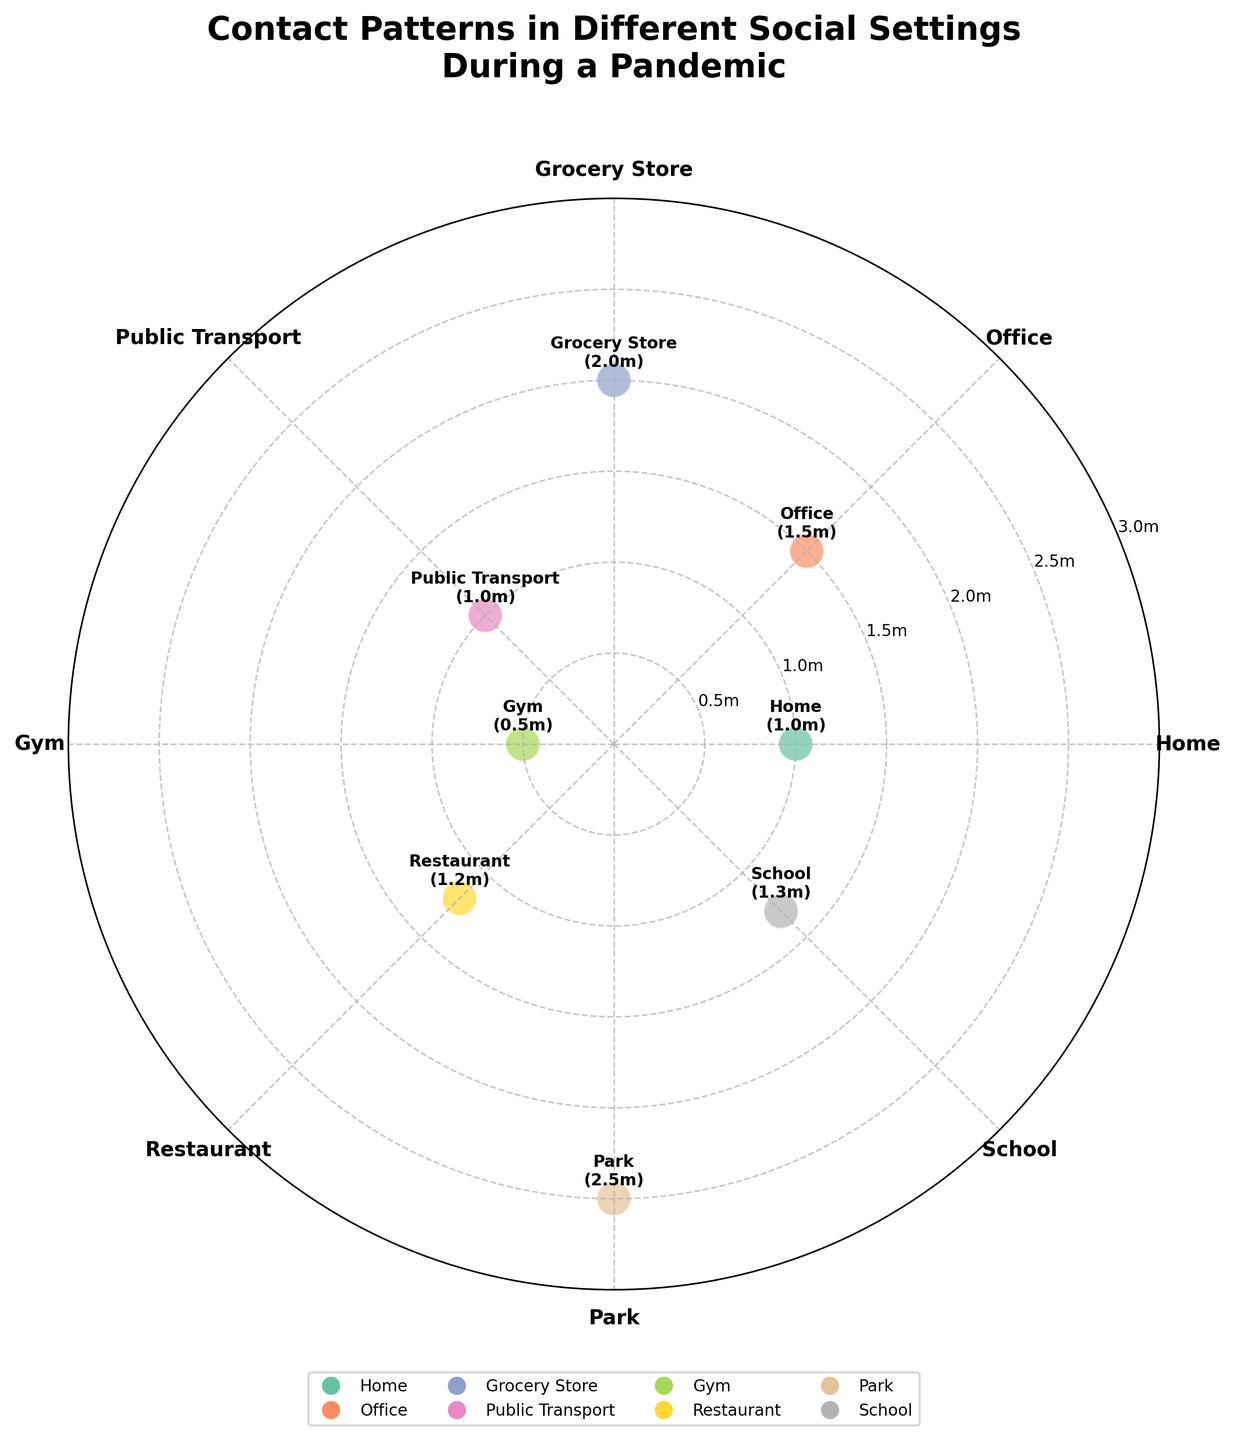What is the title of the figure? The title is located at the top of the figure and reads "Contact Patterns in Different Social Settings During a Pandemic".
Answer: Contact Patterns in Different Social Settings During a Pandemic Which social setting has the closest contact distance? According to the proximity (meters) label, the setting with the smallest value is the closest contact distance. The gym has a proximity value of 0.5 meters.
Answer: Gym How many social settings are shown in the figure? Each marker in the polar scatter chart represents a distinct social setting. By counting the settings, there are 8.
Answer: 8 What is the proximity distance for Public Transport? The proximity (meters) for Public Transport is annotated next to its marker. It reads 1 meter.
Answer: 1 meter What is the average proximity across all settings? Sum the proximity values (1+1.5+2+1+0.5+1.2+2.5+1.3) and divide by the number of settings (8). The sum is 11 and the average is 11/8 = 1.375.
Answer: 1.375 meters Which setting has a greater proximity distance, Office or School? Compare the annotated proximity distances for Office (1.5 meters) and School (1.3 meters). Office has a greater distance.
Answer: Office What is the difference in proximity between the Grocery Store and the Park? The proximity for Grocery Store is 2 meters and for Park is 2.5 meters. The difference is 2.5 - 2 = 0.5 meters.
Answer: 0.5 meters Which social setting has an angle of 135 degrees? The annotated social setting at the angle of 135 degrees is Public Transport.
Answer: Public Transport Are there any social settings with a proximity greater than 2 meters? If so, which ones? Inspect the proximity values. Both Grocery Store (2 meters) and Park (2.5 meters) have values; only Park exceeds 2 meters.
Answer: Park 